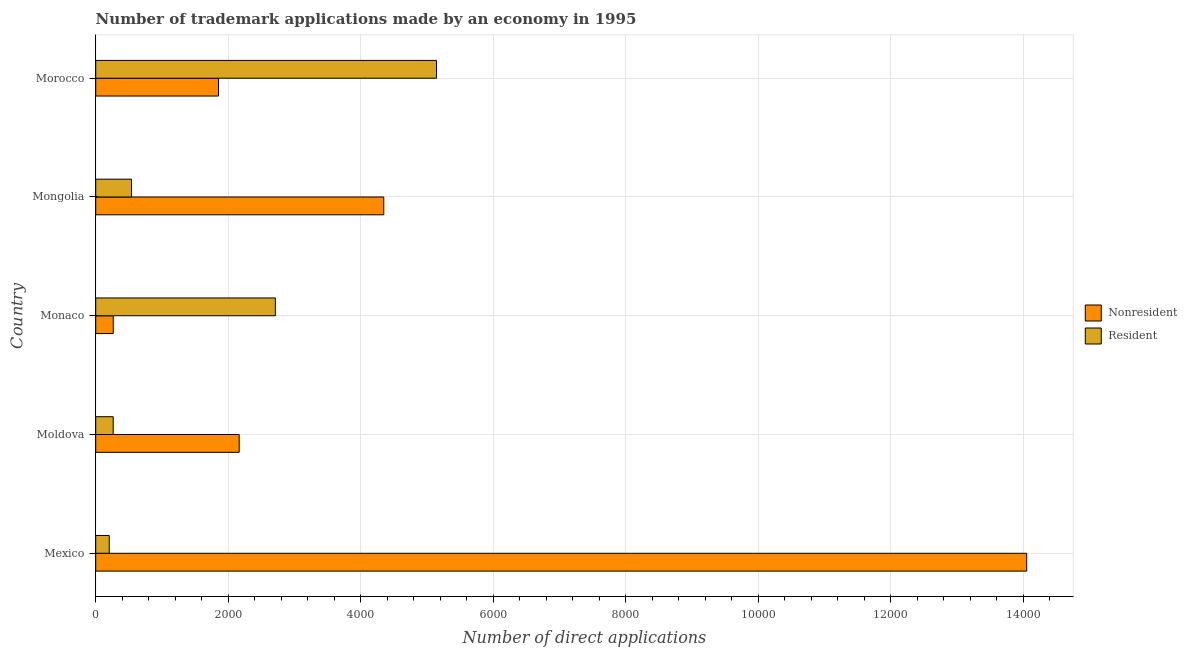How many different coloured bars are there?
Ensure brevity in your answer.  2. Are the number of bars per tick equal to the number of legend labels?
Ensure brevity in your answer.  Yes. Are the number of bars on each tick of the Y-axis equal?
Provide a succinct answer. Yes. How many bars are there on the 1st tick from the bottom?
Keep it short and to the point. 2. What is the label of the 2nd group of bars from the top?
Your answer should be compact. Mongolia. What is the number of trademark applications made by non residents in Monaco?
Your answer should be compact. 265. Across all countries, what is the maximum number of trademark applications made by non residents?
Your response must be concise. 1.40e+04. Across all countries, what is the minimum number of trademark applications made by residents?
Keep it short and to the point. 204. In which country was the number of trademark applications made by residents maximum?
Your answer should be very brief. Morocco. What is the total number of trademark applications made by residents in the graph?
Your response must be concise. 8862. What is the difference between the number of trademark applications made by non residents in Mexico and that in Mongolia?
Your response must be concise. 9702. What is the difference between the number of trademark applications made by residents in Mongolia and the number of trademark applications made by non residents in Morocco?
Your answer should be very brief. -1313. What is the average number of trademark applications made by residents per country?
Ensure brevity in your answer.  1772.4. What is the difference between the number of trademark applications made by non residents and number of trademark applications made by residents in Mexico?
Provide a short and direct response. 1.38e+04. In how many countries, is the number of trademark applications made by non residents greater than 400 ?
Ensure brevity in your answer.  4. What is the ratio of the number of trademark applications made by residents in Moldova to that in Mongolia?
Ensure brevity in your answer.  0.49. Is the number of trademark applications made by residents in Mongolia less than that in Morocco?
Offer a terse response. Yes. What is the difference between the highest and the second highest number of trademark applications made by non residents?
Provide a short and direct response. 9702. What is the difference between the highest and the lowest number of trademark applications made by non residents?
Your answer should be very brief. 1.38e+04. In how many countries, is the number of trademark applications made by residents greater than the average number of trademark applications made by residents taken over all countries?
Provide a succinct answer. 2. Is the sum of the number of trademark applications made by non residents in Moldova and Monaco greater than the maximum number of trademark applications made by residents across all countries?
Your response must be concise. No. What does the 1st bar from the top in Monaco represents?
Your answer should be compact. Resident. What does the 1st bar from the bottom in Mongolia represents?
Keep it short and to the point. Nonresident. How many countries are there in the graph?
Keep it short and to the point. 5. What is the difference between two consecutive major ticks on the X-axis?
Provide a short and direct response. 2000. Does the graph contain grids?
Ensure brevity in your answer.  Yes. What is the title of the graph?
Offer a terse response. Number of trademark applications made by an economy in 1995. What is the label or title of the X-axis?
Your response must be concise. Number of direct applications. What is the Number of direct applications of Nonresident in Mexico?
Your answer should be compact. 1.40e+04. What is the Number of direct applications of Resident in Mexico?
Give a very brief answer. 204. What is the Number of direct applications in Nonresident in Moldova?
Your answer should be very brief. 2165. What is the Number of direct applications in Resident in Moldova?
Offer a terse response. 264. What is the Number of direct applications in Nonresident in Monaco?
Give a very brief answer. 265. What is the Number of direct applications of Resident in Monaco?
Provide a short and direct response. 2711. What is the Number of direct applications of Nonresident in Mongolia?
Keep it short and to the point. 4347. What is the Number of direct applications in Resident in Mongolia?
Make the answer very short. 540. What is the Number of direct applications in Nonresident in Morocco?
Offer a very short reply. 1853. What is the Number of direct applications of Resident in Morocco?
Provide a short and direct response. 5143. Across all countries, what is the maximum Number of direct applications in Nonresident?
Ensure brevity in your answer.  1.40e+04. Across all countries, what is the maximum Number of direct applications of Resident?
Your response must be concise. 5143. Across all countries, what is the minimum Number of direct applications in Nonresident?
Your answer should be compact. 265. Across all countries, what is the minimum Number of direct applications of Resident?
Your answer should be compact. 204. What is the total Number of direct applications in Nonresident in the graph?
Offer a very short reply. 2.27e+04. What is the total Number of direct applications in Resident in the graph?
Provide a short and direct response. 8862. What is the difference between the Number of direct applications of Nonresident in Mexico and that in Moldova?
Offer a very short reply. 1.19e+04. What is the difference between the Number of direct applications of Resident in Mexico and that in Moldova?
Your response must be concise. -60. What is the difference between the Number of direct applications of Nonresident in Mexico and that in Monaco?
Keep it short and to the point. 1.38e+04. What is the difference between the Number of direct applications in Resident in Mexico and that in Monaco?
Give a very brief answer. -2507. What is the difference between the Number of direct applications in Nonresident in Mexico and that in Mongolia?
Offer a terse response. 9702. What is the difference between the Number of direct applications in Resident in Mexico and that in Mongolia?
Keep it short and to the point. -336. What is the difference between the Number of direct applications in Nonresident in Mexico and that in Morocco?
Your answer should be very brief. 1.22e+04. What is the difference between the Number of direct applications in Resident in Mexico and that in Morocco?
Provide a short and direct response. -4939. What is the difference between the Number of direct applications in Nonresident in Moldova and that in Monaco?
Make the answer very short. 1900. What is the difference between the Number of direct applications in Resident in Moldova and that in Monaco?
Provide a short and direct response. -2447. What is the difference between the Number of direct applications in Nonresident in Moldova and that in Mongolia?
Your response must be concise. -2182. What is the difference between the Number of direct applications of Resident in Moldova and that in Mongolia?
Offer a very short reply. -276. What is the difference between the Number of direct applications of Nonresident in Moldova and that in Morocco?
Offer a very short reply. 312. What is the difference between the Number of direct applications of Resident in Moldova and that in Morocco?
Provide a succinct answer. -4879. What is the difference between the Number of direct applications of Nonresident in Monaco and that in Mongolia?
Your answer should be compact. -4082. What is the difference between the Number of direct applications in Resident in Monaco and that in Mongolia?
Make the answer very short. 2171. What is the difference between the Number of direct applications of Nonresident in Monaco and that in Morocco?
Provide a short and direct response. -1588. What is the difference between the Number of direct applications of Resident in Monaco and that in Morocco?
Provide a short and direct response. -2432. What is the difference between the Number of direct applications of Nonresident in Mongolia and that in Morocco?
Your response must be concise. 2494. What is the difference between the Number of direct applications of Resident in Mongolia and that in Morocco?
Your answer should be very brief. -4603. What is the difference between the Number of direct applications in Nonresident in Mexico and the Number of direct applications in Resident in Moldova?
Your answer should be compact. 1.38e+04. What is the difference between the Number of direct applications of Nonresident in Mexico and the Number of direct applications of Resident in Monaco?
Your response must be concise. 1.13e+04. What is the difference between the Number of direct applications of Nonresident in Mexico and the Number of direct applications of Resident in Mongolia?
Ensure brevity in your answer.  1.35e+04. What is the difference between the Number of direct applications of Nonresident in Mexico and the Number of direct applications of Resident in Morocco?
Your response must be concise. 8906. What is the difference between the Number of direct applications of Nonresident in Moldova and the Number of direct applications of Resident in Monaco?
Make the answer very short. -546. What is the difference between the Number of direct applications of Nonresident in Moldova and the Number of direct applications of Resident in Mongolia?
Keep it short and to the point. 1625. What is the difference between the Number of direct applications of Nonresident in Moldova and the Number of direct applications of Resident in Morocco?
Your answer should be compact. -2978. What is the difference between the Number of direct applications of Nonresident in Monaco and the Number of direct applications of Resident in Mongolia?
Provide a short and direct response. -275. What is the difference between the Number of direct applications of Nonresident in Monaco and the Number of direct applications of Resident in Morocco?
Keep it short and to the point. -4878. What is the difference between the Number of direct applications in Nonresident in Mongolia and the Number of direct applications in Resident in Morocco?
Provide a succinct answer. -796. What is the average Number of direct applications of Nonresident per country?
Make the answer very short. 4535.8. What is the average Number of direct applications of Resident per country?
Your answer should be compact. 1772.4. What is the difference between the Number of direct applications in Nonresident and Number of direct applications in Resident in Mexico?
Make the answer very short. 1.38e+04. What is the difference between the Number of direct applications in Nonresident and Number of direct applications in Resident in Moldova?
Your response must be concise. 1901. What is the difference between the Number of direct applications of Nonresident and Number of direct applications of Resident in Monaco?
Your answer should be compact. -2446. What is the difference between the Number of direct applications of Nonresident and Number of direct applications of Resident in Mongolia?
Provide a succinct answer. 3807. What is the difference between the Number of direct applications of Nonresident and Number of direct applications of Resident in Morocco?
Offer a very short reply. -3290. What is the ratio of the Number of direct applications in Nonresident in Mexico to that in Moldova?
Give a very brief answer. 6.49. What is the ratio of the Number of direct applications in Resident in Mexico to that in Moldova?
Your answer should be very brief. 0.77. What is the ratio of the Number of direct applications in Nonresident in Mexico to that in Monaco?
Make the answer very short. 53.02. What is the ratio of the Number of direct applications of Resident in Mexico to that in Monaco?
Give a very brief answer. 0.08. What is the ratio of the Number of direct applications of Nonresident in Mexico to that in Mongolia?
Keep it short and to the point. 3.23. What is the ratio of the Number of direct applications of Resident in Mexico to that in Mongolia?
Ensure brevity in your answer.  0.38. What is the ratio of the Number of direct applications in Nonresident in Mexico to that in Morocco?
Keep it short and to the point. 7.58. What is the ratio of the Number of direct applications in Resident in Mexico to that in Morocco?
Offer a very short reply. 0.04. What is the ratio of the Number of direct applications of Nonresident in Moldova to that in Monaco?
Give a very brief answer. 8.17. What is the ratio of the Number of direct applications in Resident in Moldova to that in Monaco?
Your answer should be compact. 0.1. What is the ratio of the Number of direct applications in Nonresident in Moldova to that in Mongolia?
Ensure brevity in your answer.  0.5. What is the ratio of the Number of direct applications in Resident in Moldova to that in Mongolia?
Keep it short and to the point. 0.49. What is the ratio of the Number of direct applications of Nonresident in Moldova to that in Morocco?
Provide a short and direct response. 1.17. What is the ratio of the Number of direct applications of Resident in Moldova to that in Morocco?
Give a very brief answer. 0.05. What is the ratio of the Number of direct applications in Nonresident in Monaco to that in Mongolia?
Offer a terse response. 0.06. What is the ratio of the Number of direct applications in Resident in Monaco to that in Mongolia?
Your response must be concise. 5.02. What is the ratio of the Number of direct applications in Nonresident in Monaco to that in Morocco?
Make the answer very short. 0.14. What is the ratio of the Number of direct applications in Resident in Monaco to that in Morocco?
Provide a succinct answer. 0.53. What is the ratio of the Number of direct applications of Nonresident in Mongolia to that in Morocco?
Make the answer very short. 2.35. What is the ratio of the Number of direct applications of Resident in Mongolia to that in Morocco?
Offer a terse response. 0.1. What is the difference between the highest and the second highest Number of direct applications of Nonresident?
Keep it short and to the point. 9702. What is the difference between the highest and the second highest Number of direct applications of Resident?
Keep it short and to the point. 2432. What is the difference between the highest and the lowest Number of direct applications of Nonresident?
Offer a terse response. 1.38e+04. What is the difference between the highest and the lowest Number of direct applications of Resident?
Offer a very short reply. 4939. 